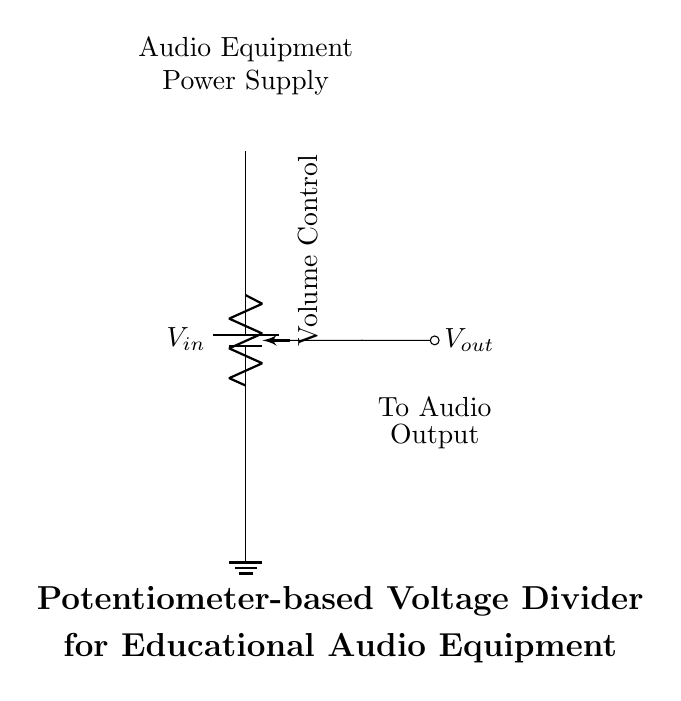What is the input voltage labeled in the circuit? The input voltage is labeled as V in, which indicates the voltage supplied to the circuit.
Answer: V in What type of component is used for volume control in this circuit? The component used for volume control is a potentiometer, as indicated by the label "Volume Control" in the diagram.
Answer: Potentiometer Where is the output voltage taken from in this circuit? The output voltage, labeled as V out, is taken from the wiper of the potentiometer, which connects to the audio output.
Answer: Wiper of the potentiometer What will happen if the potentiometer is turned to its maximum position? If the potentiometer is turned to its maximum position, the output voltage will approach the input voltage, maximizing the volume output.
Answer: Output voltage approaches V in How does the potentiometer affect the output voltage? The potentiometer adjusts the resistance in the circuit, allowing varying amounts of input voltage to pass through, which changes the output voltage.
Answer: It varies the resistance What is the function of the ground symbol in this circuit? The ground symbol indicates a reference point for the voltage levels in the circuit, providing a common return path for current.
Answer: Reference point Can this circuit be used to control the volume of other audio devices? Yes, this circuit can be adapted for use with other audio equipment that requires voltage control for volume adjustment.
Answer: Yes 